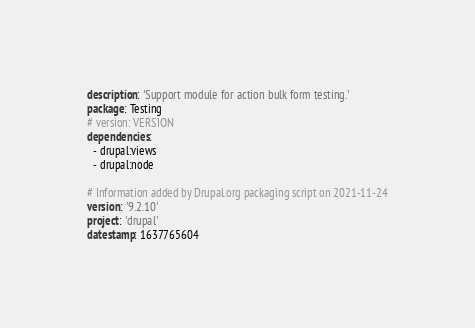Convert code to text. <code><loc_0><loc_0><loc_500><loc_500><_YAML_>description: 'Support module for action bulk form testing.'
package: Testing
# version: VERSION
dependencies:
  - drupal:views
  - drupal:node

# Information added by Drupal.org packaging script on 2021-11-24
version: '9.2.10'
project: 'drupal'
datestamp: 1637765604
</code> 